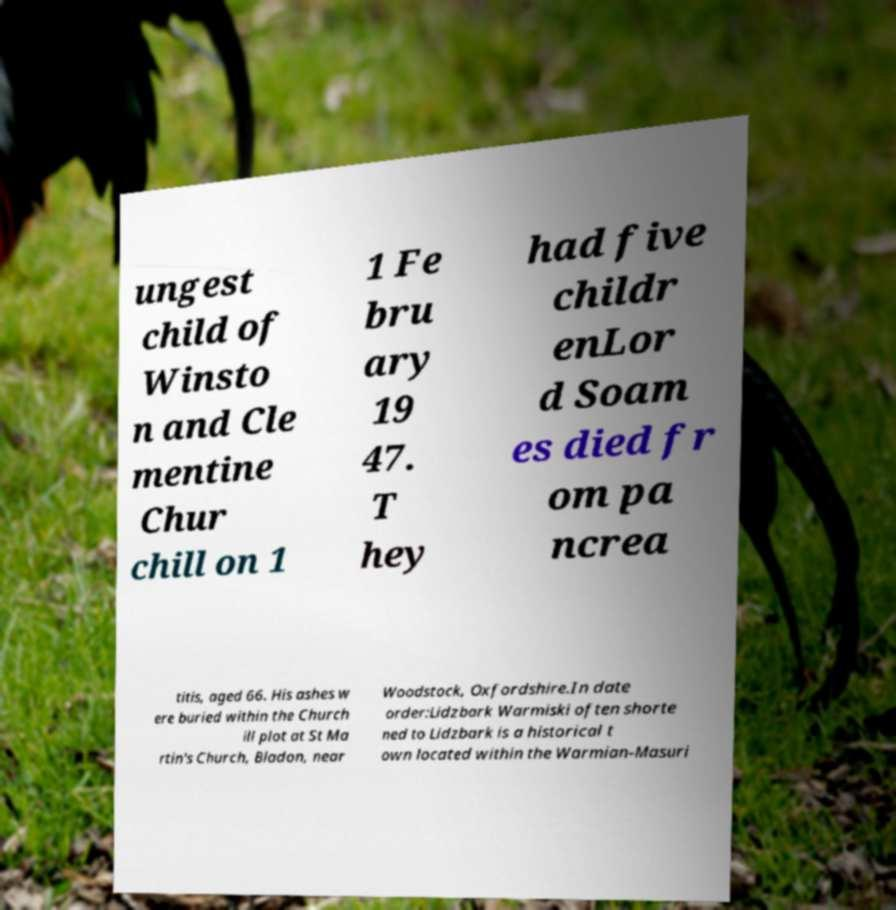What messages or text are displayed in this image? I need them in a readable, typed format. ungest child of Winsto n and Cle mentine Chur chill on 1 1 Fe bru ary 19 47. T hey had five childr enLor d Soam es died fr om pa ncrea titis, aged 66. His ashes w ere buried within the Church ill plot at St Ma rtin's Church, Bladon, near Woodstock, Oxfordshire.In date order:Lidzbark Warmiski often shorte ned to Lidzbark is a historical t own located within the Warmian-Masuri 